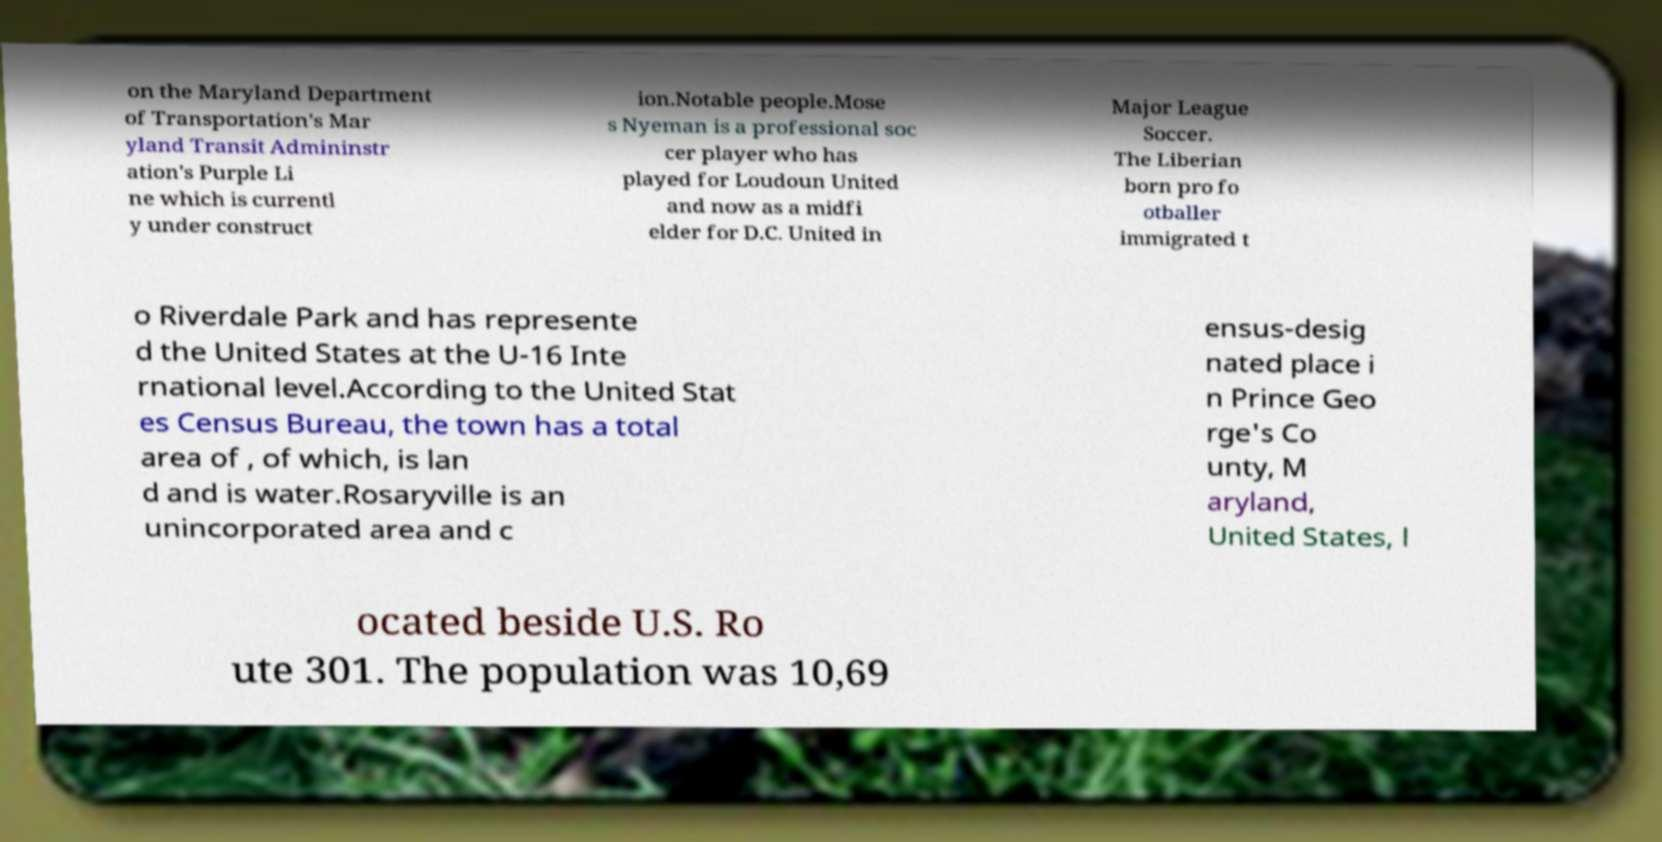Could you assist in decoding the text presented in this image and type it out clearly? on the Maryland Department of Transportation's Mar yland Transit Admininstr ation's Purple Li ne which is currentl y under construct ion.Notable people.Mose s Nyeman is a professional soc cer player who has played for Loudoun United and now as a midfi elder for D.C. United in Major League Soccer. The Liberian born pro fo otballer immigrated t o Riverdale Park and has represente d the United States at the U-16 Inte rnational level.According to the United Stat es Census Bureau, the town has a total area of , of which, is lan d and is water.Rosaryville is an unincorporated area and c ensus-desig nated place i n Prince Geo rge's Co unty, M aryland, United States, l ocated beside U.S. Ro ute 301. The population was 10,69 